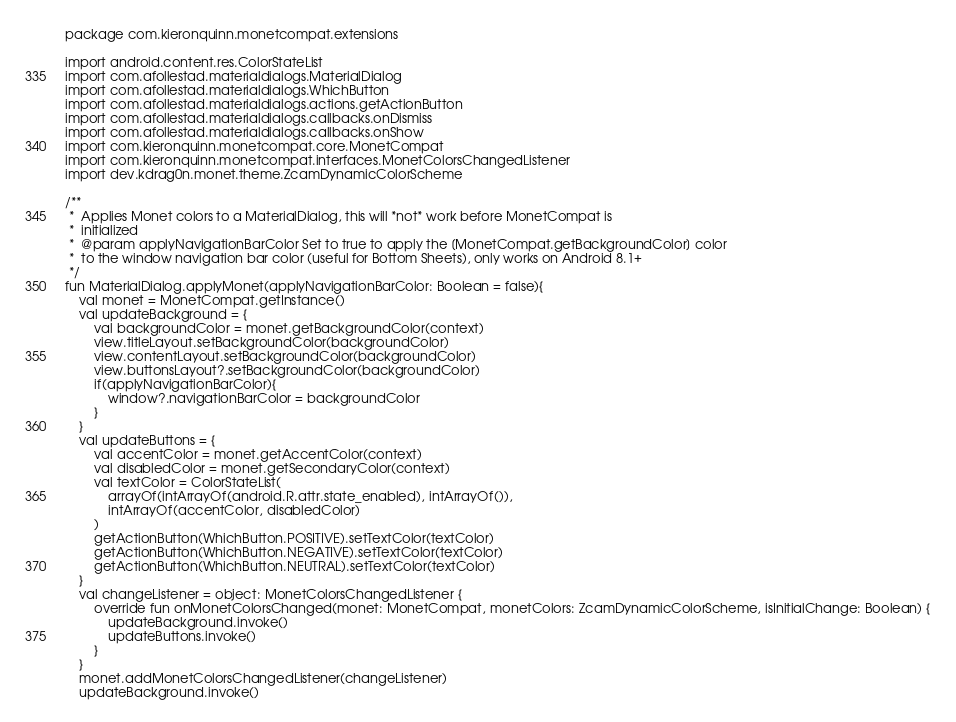<code> <loc_0><loc_0><loc_500><loc_500><_Kotlin_>package com.kieronquinn.monetcompat.extensions

import android.content.res.ColorStateList
import com.afollestad.materialdialogs.MaterialDialog
import com.afollestad.materialdialogs.WhichButton
import com.afollestad.materialdialogs.actions.getActionButton
import com.afollestad.materialdialogs.callbacks.onDismiss
import com.afollestad.materialdialogs.callbacks.onShow
import com.kieronquinn.monetcompat.core.MonetCompat
import com.kieronquinn.monetcompat.interfaces.MonetColorsChangedListener
import dev.kdrag0n.monet.theme.ZcamDynamicColorScheme

/**
 *  Applies Monet colors to a MaterialDialog, this will *not* work before MonetCompat is
 *  initialized
 *  @param applyNavigationBarColor Set to true to apply the [MonetCompat.getBackgroundColor] color
 *  to the window navigation bar color (useful for Bottom Sheets), only works on Android 8.1+
 */
fun MaterialDialog.applyMonet(applyNavigationBarColor: Boolean = false){
    val monet = MonetCompat.getInstance()
    val updateBackground = {
        val backgroundColor = monet.getBackgroundColor(context)
        view.titleLayout.setBackgroundColor(backgroundColor)
        view.contentLayout.setBackgroundColor(backgroundColor)
        view.buttonsLayout?.setBackgroundColor(backgroundColor)
        if(applyNavigationBarColor){
            window?.navigationBarColor = backgroundColor
        }
    }
    val updateButtons = {
        val accentColor = monet.getAccentColor(context)
        val disabledColor = monet.getSecondaryColor(context)
        val textColor = ColorStateList(
            arrayOf(intArrayOf(android.R.attr.state_enabled), intArrayOf()),
            intArrayOf(accentColor, disabledColor)
        )
        getActionButton(WhichButton.POSITIVE).setTextColor(textColor)
        getActionButton(WhichButton.NEGATIVE).setTextColor(textColor)
        getActionButton(WhichButton.NEUTRAL).setTextColor(textColor)
    }
    val changeListener = object: MonetColorsChangedListener {
        override fun onMonetColorsChanged(monet: MonetCompat, monetColors: ZcamDynamicColorScheme, isInitialChange: Boolean) {
            updateBackground.invoke()
            updateButtons.invoke()
        }
    }
    monet.addMonetColorsChangedListener(changeListener)
    updateBackground.invoke()</code> 